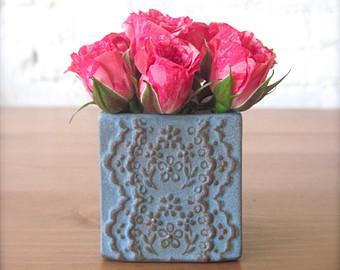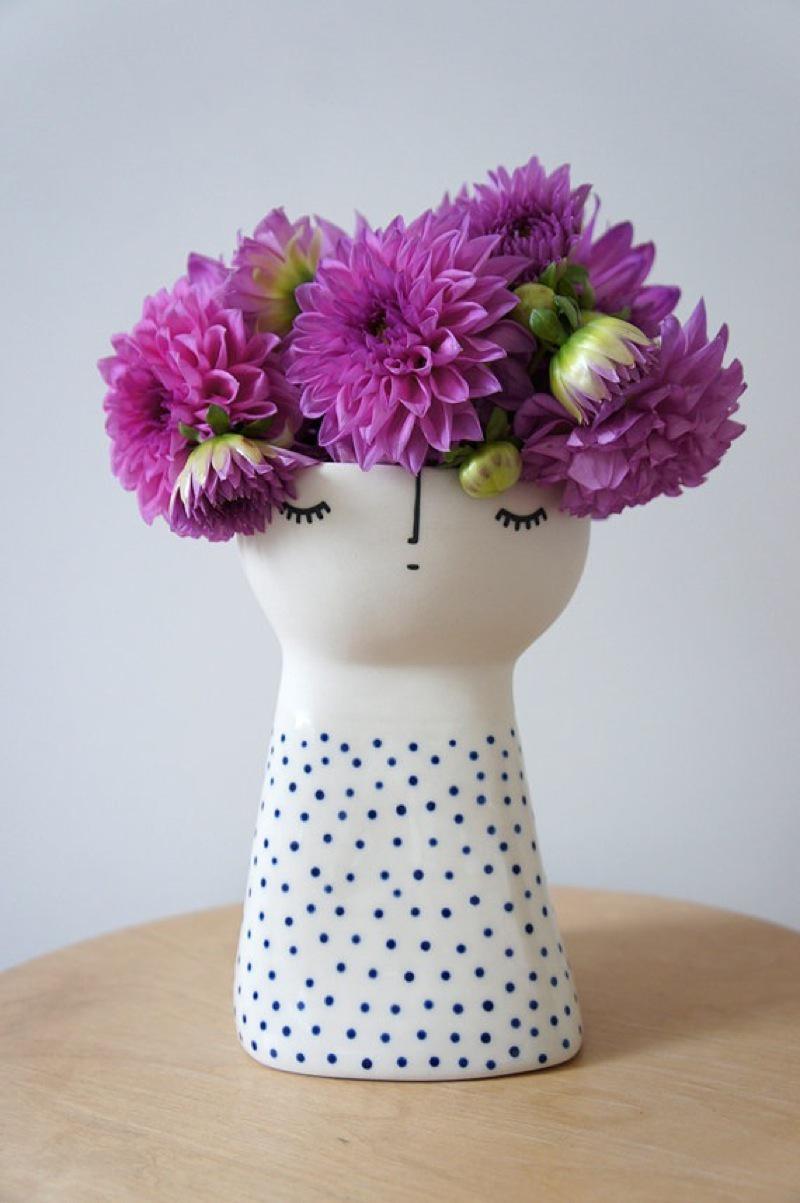The first image is the image on the left, the second image is the image on the right. Examine the images to the left and right. Is the description "The left image features a square vase displayed head-on that holds only dark pink roses." accurate? Answer yes or no. Yes. The first image is the image on the left, the second image is the image on the right. Considering the images on both sides, is "The vase on the left contains all pink flowers, while the vase on the right contains at least some purple flowers." valid? Answer yes or no. Yes. 